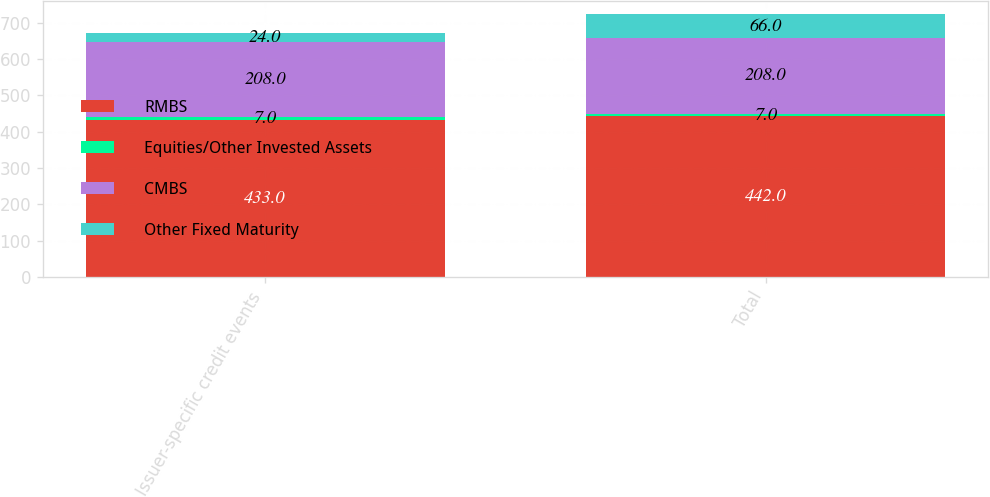Convert chart. <chart><loc_0><loc_0><loc_500><loc_500><stacked_bar_chart><ecel><fcel>Issuer-specific credit events<fcel>Total<nl><fcel>RMBS<fcel>433<fcel>442<nl><fcel>Equities/Other Invested Assets<fcel>7<fcel>7<nl><fcel>CMBS<fcel>208<fcel>208<nl><fcel>Other Fixed Maturity<fcel>24<fcel>66<nl></chart> 